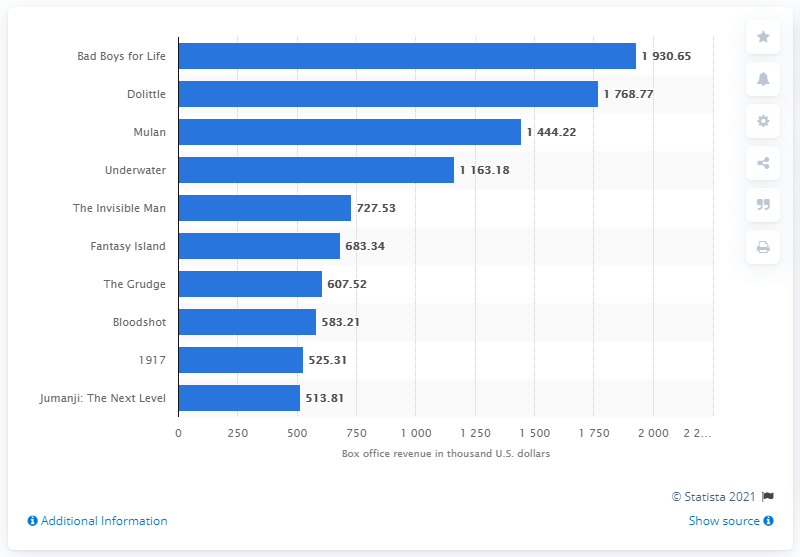Mention a couple of crucial points in this snapshot. Dolittle, the movie, was the highest-grossing film in Malaysia, earning approximately 1.77 million U.S. dollars in revenue. In 2020, the movie "Bad Boys for Life" topped the Malaysian box office, becoming the highest-grossing film of the year. In 2020, the movie Bad Boys for Life earned a total of 1930.65 in Malaysia. 